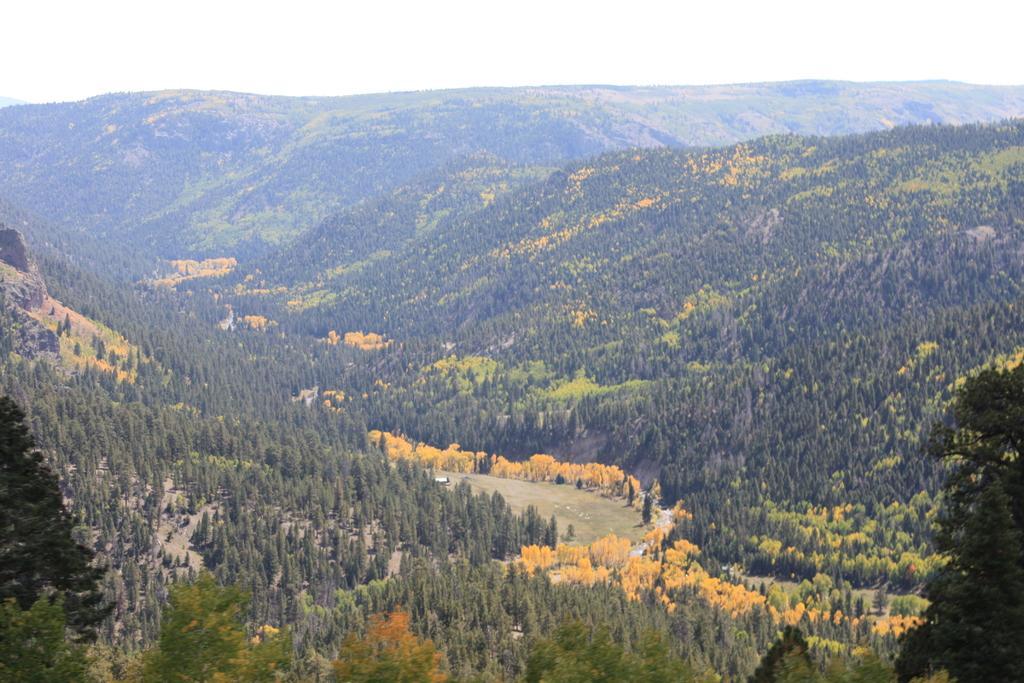Can you describe this image briefly? In this image I can see trees and hills. There is a road in the center. There is sky at the top. 